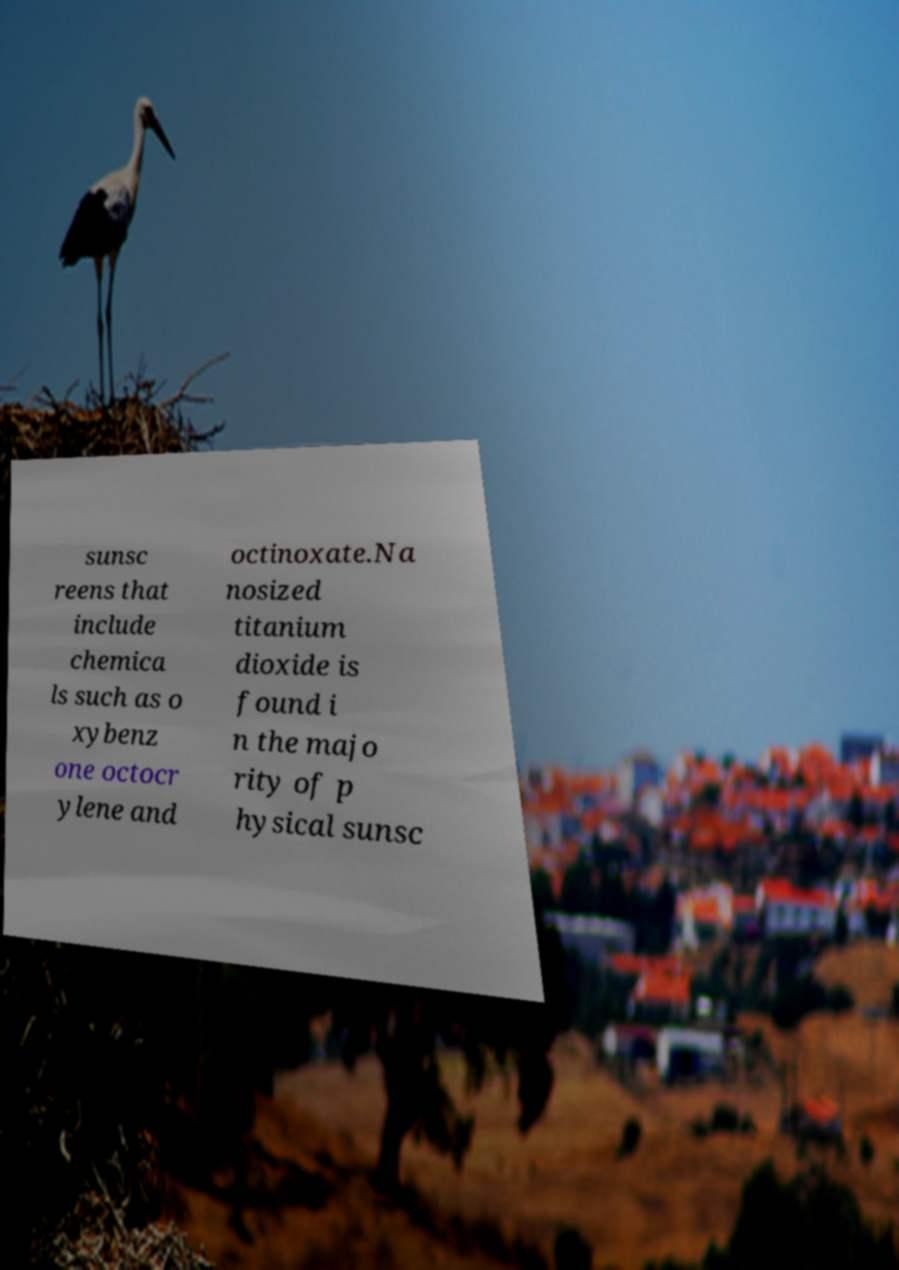Can you accurately transcribe the text from the provided image for me? sunsc reens that include chemica ls such as o xybenz one octocr ylene and octinoxate.Na nosized titanium dioxide is found i n the majo rity of p hysical sunsc 